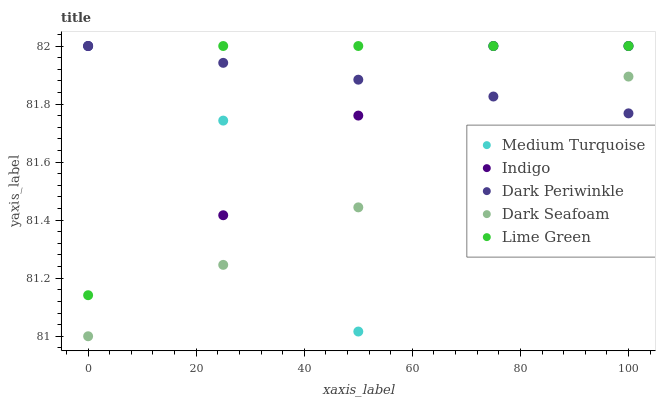Does Dark Seafoam have the minimum area under the curve?
Answer yes or no. Yes. Does Lime Green have the maximum area under the curve?
Answer yes or no. Yes. Does Indigo have the minimum area under the curve?
Answer yes or no. No. Does Indigo have the maximum area under the curve?
Answer yes or no. No. Is Dark Periwinkle the smoothest?
Answer yes or no. Yes. Is Medium Turquoise the roughest?
Answer yes or no. Yes. Is Dark Seafoam the smoothest?
Answer yes or no. No. Is Dark Seafoam the roughest?
Answer yes or no. No. Does Dark Seafoam have the lowest value?
Answer yes or no. Yes. Does Indigo have the lowest value?
Answer yes or no. No. Does Medium Turquoise have the highest value?
Answer yes or no. Yes. Does Dark Seafoam have the highest value?
Answer yes or no. No. Is Dark Seafoam less than Indigo?
Answer yes or no. Yes. Is Indigo greater than Dark Seafoam?
Answer yes or no. Yes. Does Medium Turquoise intersect Dark Seafoam?
Answer yes or no. Yes. Is Medium Turquoise less than Dark Seafoam?
Answer yes or no. No. Is Medium Turquoise greater than Dark Seafoam?
Answer yes or no. No. Does Dark Seafoam intersect Indigo?
Answer yes or no. No. 